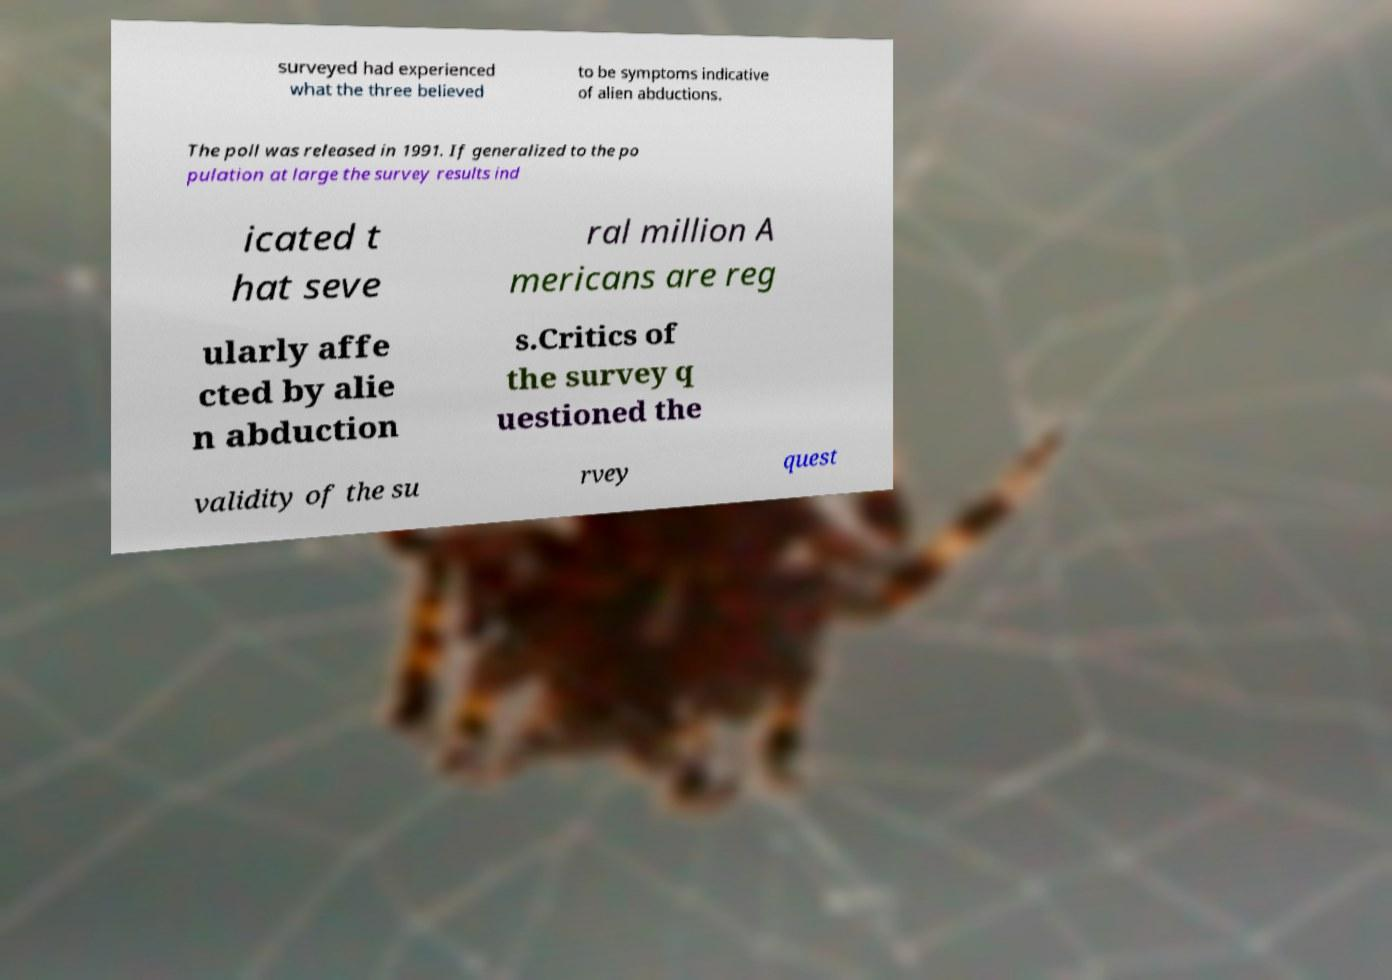I need the written content from this picture converted into text. Can you do that? surveyed had experienced what the three believed to be symptoms indicative of alien abductions. The poll was released in 1991. If generalized to the po pulation at large the survey results ind icated t hat seve ral million A mericans are reg ularly affe cted by alie n abduction s.Critics of the survey q uestioned the validity of the su rvey quest 